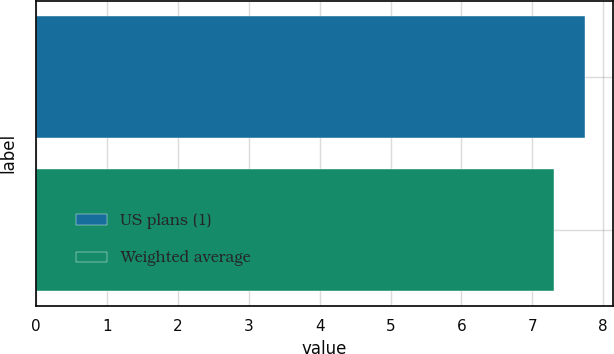<chart> <loc_0><loc_0><loc_500><loc_500><bar_chart><fcel>US plans (1)<fcel>Weighted average<nl><fcel>7.75<fcel>7.31<nl></chart> 